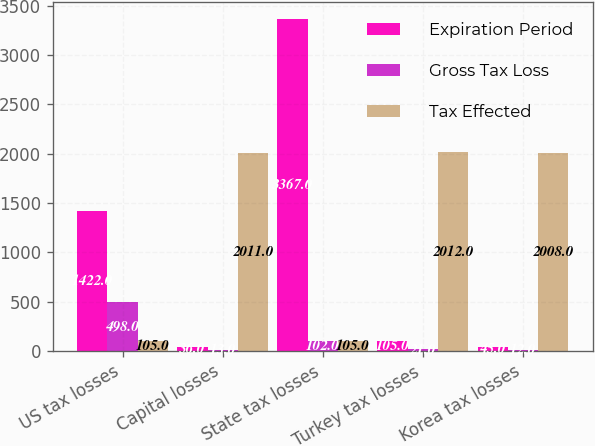Convert chart to OTSL. <chart><loc_0><loc_0><loc_500><loc_500><stacked_bar_chart><ecel><fcel>US tax losses<fcel>Capital losses<fcel>State tax losses<fcel>Turkey tax losses<fcel>Korea tax losses<nl><fcel>Expiration Period<fcel>1422<fcel>36<fcel>3367<fcel>105<fcel>45<nl><fcel>Gross Tax Loss<fcel>498<fcel>13<fcel>102<fcel>21<fcel>12<nl><fcel>Tax Effected<fcel>105<fcel>2011<fcel>105<fcel>2012<fcel>2008<nl></chart> 